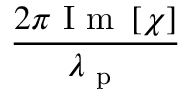<formula> <loc_0><loc_0><loc_500><loc_500>\frac { 2 \pi I m \left [ \chi \right ] } { \lambda _ { p } }</formula> 